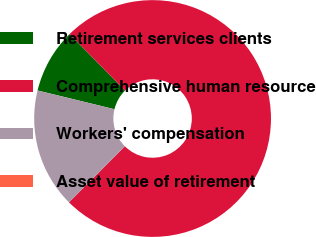Convert chart. <chart><loc_0><loc_0><loc_500><loc_500><pie_chart><fcel>Retirement services clients<fcel>Comprehensive human resource<fcel>Workers' compensation<fcel>Asset value of retirement<nl><fcel>8.83%<fcel>74.85%<fcel>16.32%<fcel>0.0%<nl></chart> 